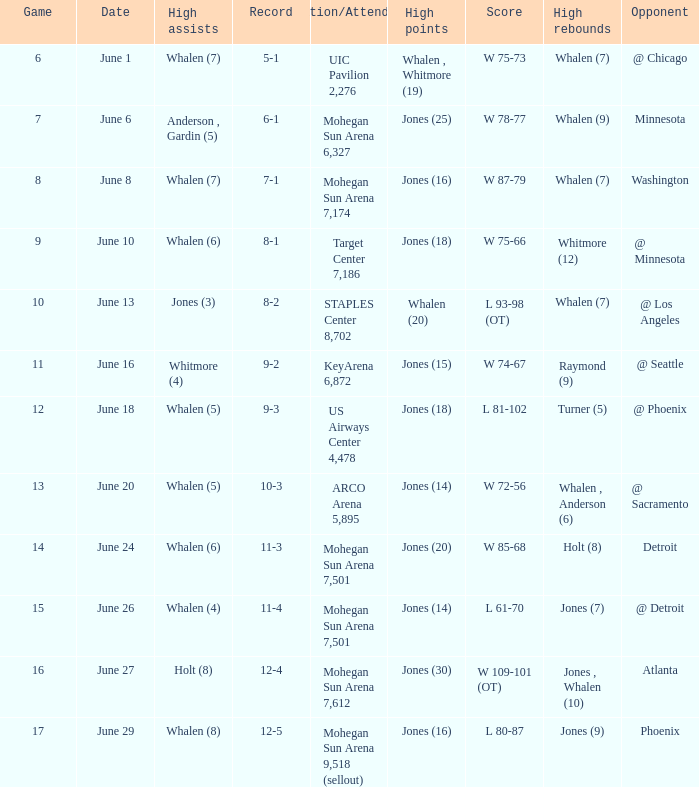What is the location/attendance when the record is 9-2? KeyArena 6,872. 